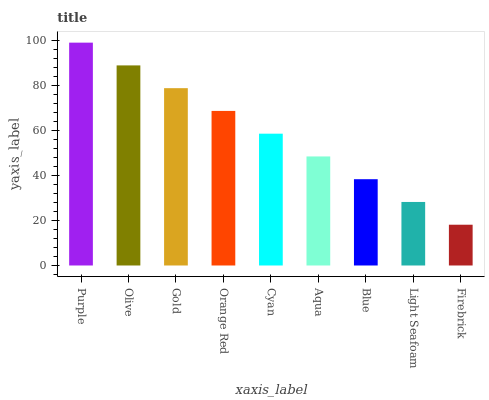Is Firebrick the minimum?
Answer yes or no. Yes. Is Purple the maximum?
Answer yes or no. Yes. Is Olive the minimum?
Answer yes or no. No. Is Olive the maximum?
Answer yes or no. No. Is Purple greater than Olive?
Answer yes or no. Yes. Is Olive less than Purple?
Answer yes or no. Yes. Is Olive greater than Purple?
Answer yes or no. No. Is Purple less than Olive?
Answer yes or no. No. Is Cyan the high median?
Answer yes or no. Yes. Is Cyan the low median?
Answer yes or no. Yes. Is Orange Red the high median?
Answer yes or no. No. Is Aqua the low median?
Answer yes or no. No. 